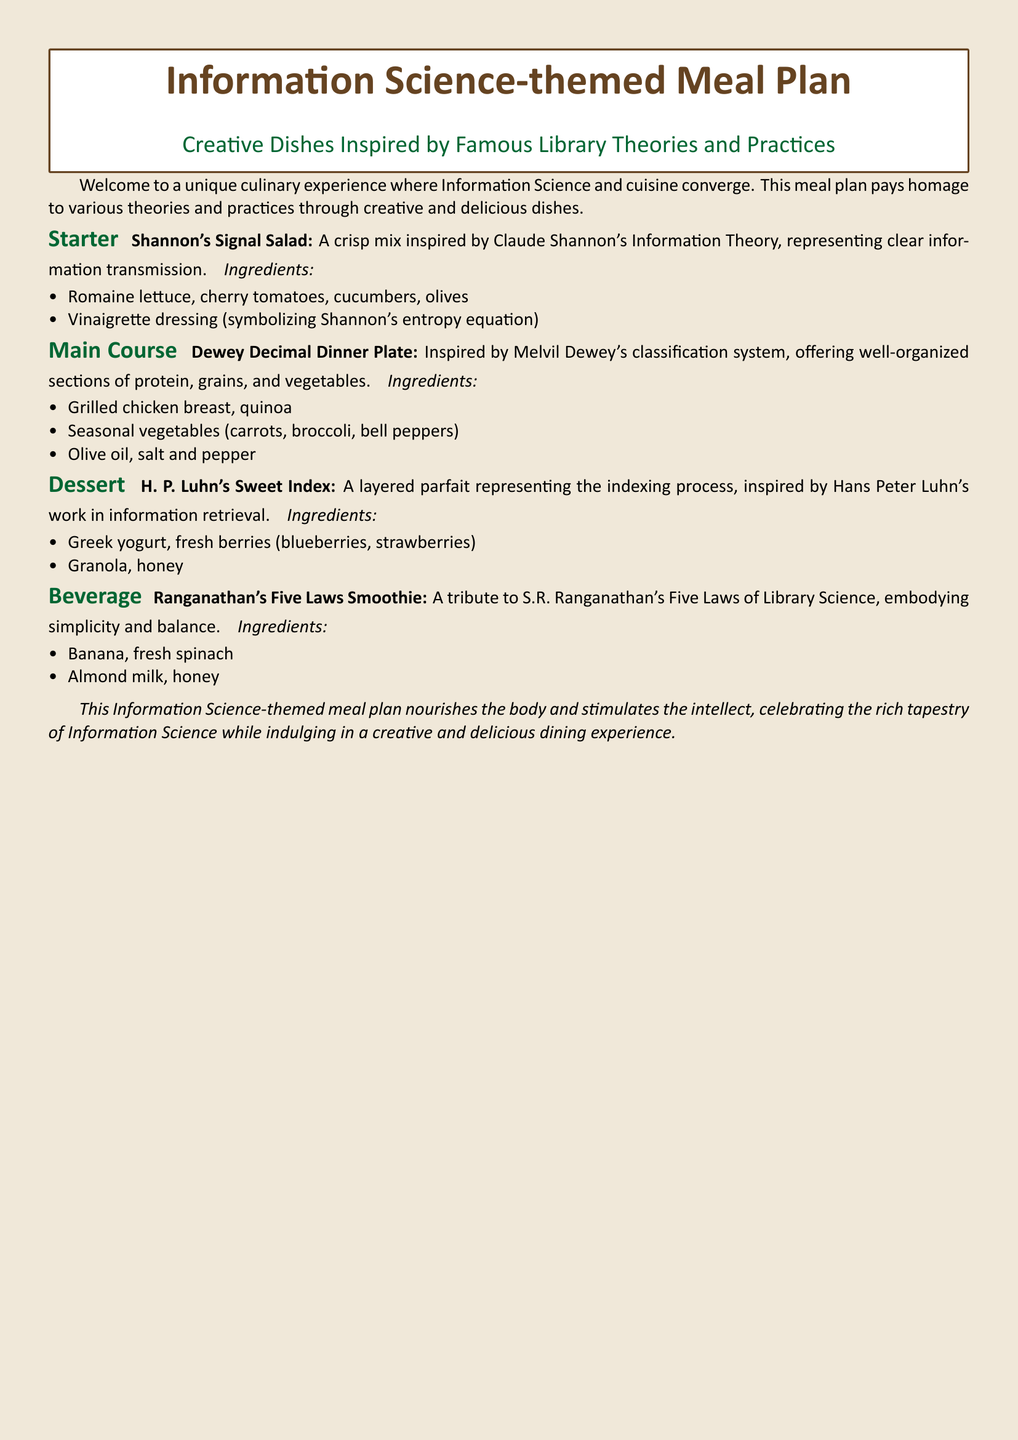What is the name of the starter dish? The starter dish is named "Shannon's Signal Salad" as mentioned in the meal plan.
Answer: Shannon's Signal Salad What ingredient symbolizes Shannon's entropy equation? The vinaigrette dressing is mentioned as symbolizing Shannon's entropy equation in the dish description.
Answer: Vinaigrette dressing Which library theory inspired the dessert? The dessert "H. P. Luhn's Sweet Index" is inspired by Hans Peter Luhn's work in information retrieval.
Answer: Hans Peter Luhn What is the main ingredient in Ranganathan's Five Laws Smoothie? The main ingredient listed for the smoothie is banana, as mentioned in the ingredients section.
Answer: Banana How many dishes are presented in the meal plan? There are four distinct dishes presented: a starter, main course, dessert, and beverage.
Answer: Four What type of dish is the "Dewey Decimal Dinner Plate"? The "Dewey Decimal Dinner Plate" is identified as the main course in the meal plan structure.
Answer: Main Course Which ingredient is NOT listed in the ingredients for the dessert? Granola is part of the parfait ingredients and is not listed as an ingredient for any other dish.
Answer: Granola What does the meal plan celebrate? The meal plan celebrates the rich tapestry of Information Science through its creative dishes.
Answer: Information Science 